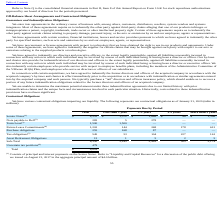According to Vmware's financial document, What did the Senior Notes consists of? principal and interest payments on the Senior Notes. The document states: "(1) Consists of principal and interest payments on the Senior Notes. Refer to “Liquidity and Capital Resources” for a discussion of the public debt of..." Also, What was the total term loans? According to the financial document, 1,500 (in millions). The relevant text states: "Term Loan (3) 1,500 1,500 — — —..." Also, What were the total future lease commitments? According to the financial document, 1,202 (in millions). The relevant text states: "Future Lease Commitments (4) 1,202 144 268 178 612..." Also, can you calculate: What was the difference between total Senior Notes and total Notes payable to Dell? Based on the calculation: 4,552-283, the result is 4269 (in millions). This is based on the information: "Note payable to Dell (2) 283 5 278 — — Senior Notes (1) $ 4,552 $ 1,372 $ 1,686 $ 98 $ 1,396..." The key data points involved are: 283, 4,552. Also, can you calculate: What was the difference between total Term Loans and total Future Lease Commitments? Based on the calculation: 1,500-1,202, the result is 298 (in millions). This is based on the information: "Term Loan (3) 1,500 1,500 — — — Future Lease Commitments (4) 1,202 144 268 178 612..." The key data points involved are: 1,202, 1,500. Also, can you calculate: What was the total Senior Notes as a percentage of total contractual obligations? Based on the calculation: 4,552/8,829, the result is 51.56 (percentage). This is based on the information: "Senior Notes (1) $ 4,552 $ 1,372 $ 1,686 $ 98 $ 1,396 Total $ 8,829..." The key data points involved are: 4,552, 8,829. 